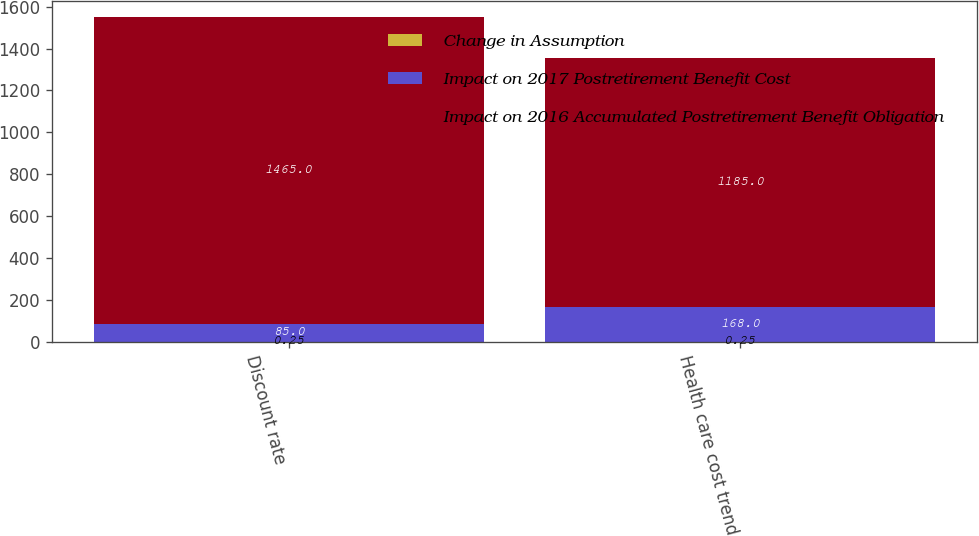Convert chart. <chart><loc_0><loc_0><loc_500><loc_500><stacked_bar_chart><ecel><fcel>Discount rate<fcel>Health care cost trend<nl><fcel>Change in Assumption<fcel>0.25<fcel>0.25<nl><fcel>Impact on 2017 Postretirement Benefit Cost<fcel>85<fcel>168<nl><fcel>Impact on 2016 Accumulated Postretirement Benefit Obligation<fcel>1465<fcel>1185<nl></chart> 